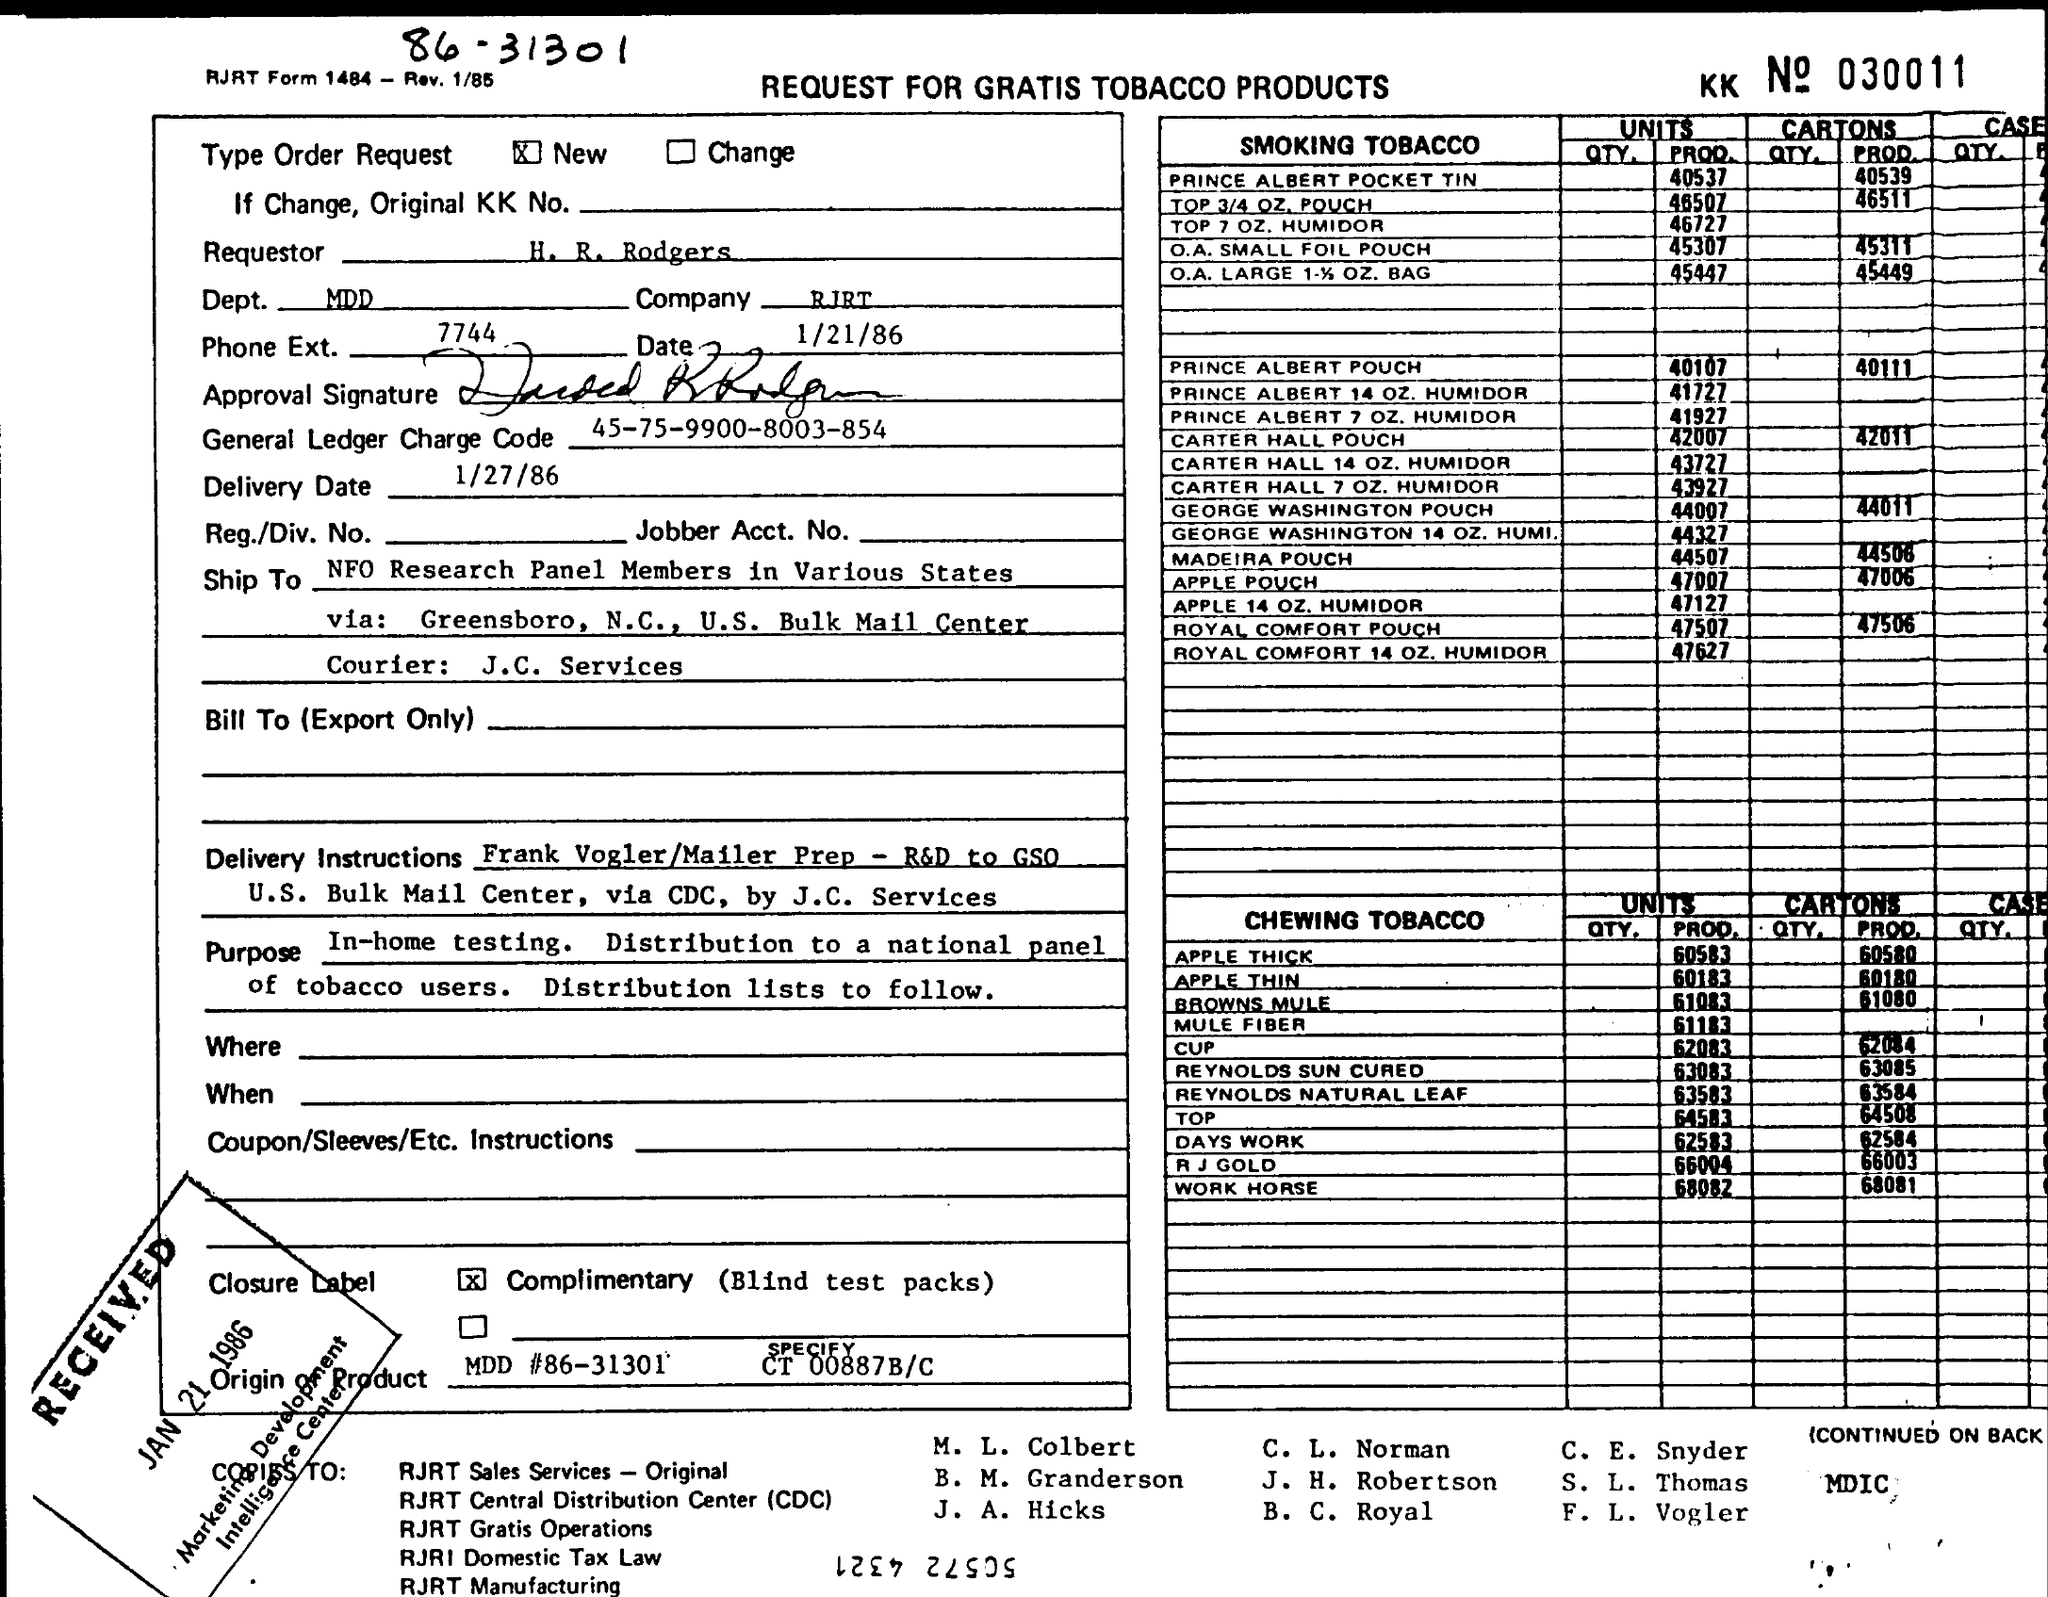Specify some key components in this picture. The name of the courier service used is J.C. Services. The units produced of the O.A.SMALL FOIL POUCH are 45307. There are 6,6003 cartons (PROD) of chewing tobacco in R.J Gold. 